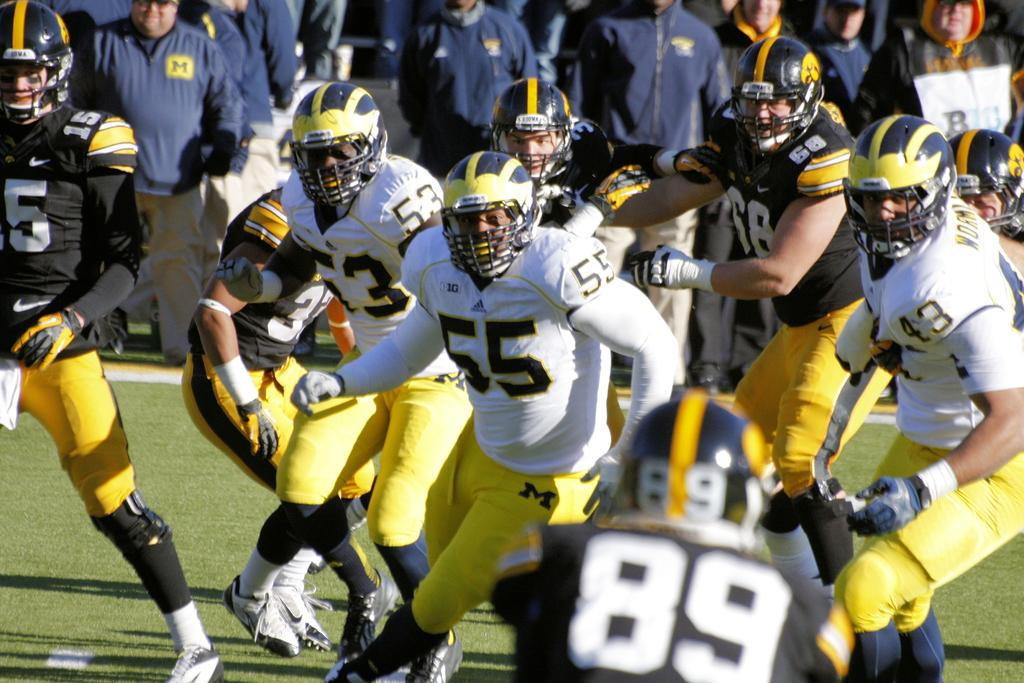What are the players in the image doing? The players in the image are playing on the ground. Can you describe the surface on which the players are playing? The players are playing on the ground. What is the rate of the donkey running in the image? There is no donkey present in the image, so it is not possible to determine the rate at which it might be running. 